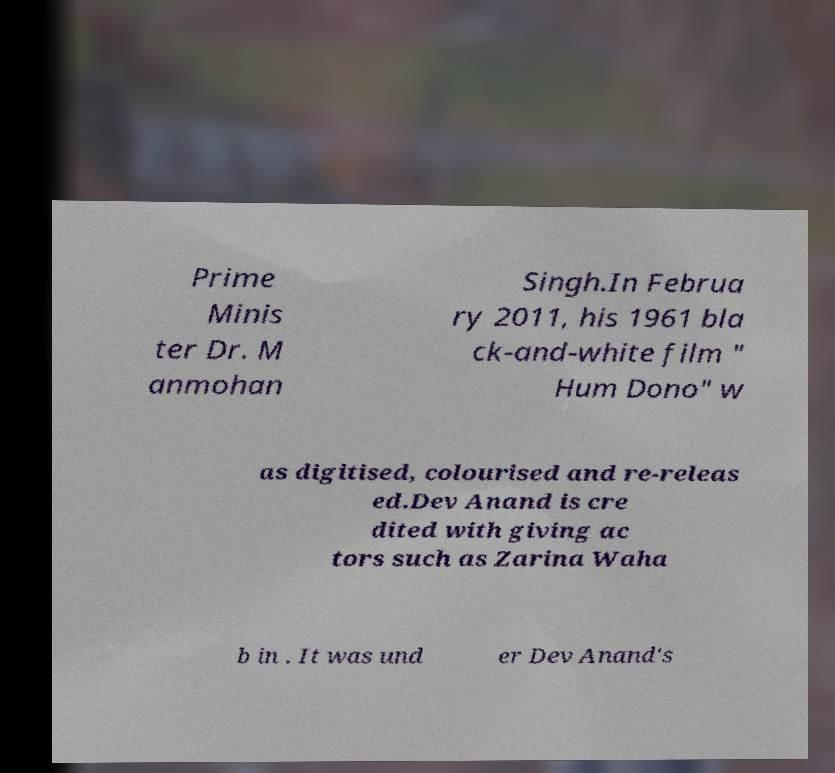I need the written content from this picture converted into text. Can you do that? Prime Minis ter Dr. M anmohan Singh.In Februa ry 2011, his 1961 bla ck-and-white film " Hum Dono" w as digitised, colourised and re-releas ed.Dev Anand is cre dited with giving ac tors such as Zarina Waha b in . It was und er Dev Anand's 